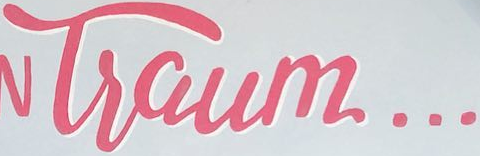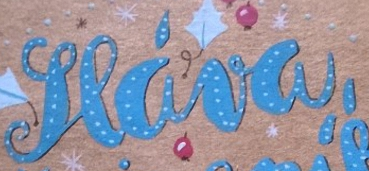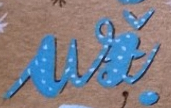What words can you see in these images in sequence, separated by a semicolon? Tsaum...; seáva,; ui 